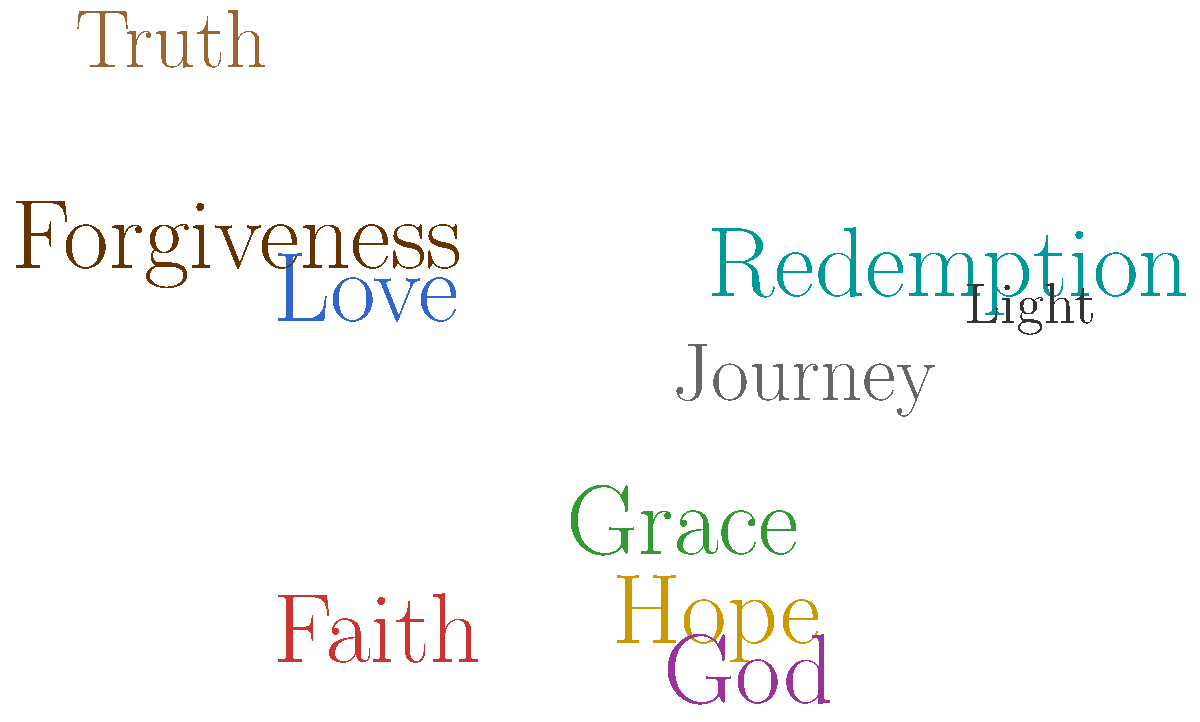Based on the word cloud representing Shawn McDonald's lyrical themes, which concept appears to be the most prominent and central to his music? To answer this question, we need to analyze the word cloud and consider the following steps:

1. Examine the size of the words: In a word cloud, the size of each word typically represents its frequency or importance in the subject matter.

2. Look for the largest word: In this word cloud, the word "God" appears to be the largest, indicating it's the most prominent theme.

3. Consider the color and positioning: While color and positioning can sometimes provide additional context, in this case, the size is the most crucial factor.

4. Reflect on Shawn McDonald's music: As a die-hard fan, you'd recognize that "God" being the central theme aligns with McDonald's Christian music background and his focus on faith-based lyrics.

5. Examine other prominent words: Words like "Love," "Faith," and "Grace" are also relatively large, supporting the overall spiritual and religious theme of McDonald's music.

6. Connect to McDonald's authenticity: The prominence of "God" in his lyrics reflects the honesty and authenticity in his music, which is something you, as a fan who appreciates these qualities, would recognize.

Therefore, based on the word cloud and our understanding of Shawn McDonald's music, the most prominent and central concept in his lyrical themes is "God."
Answer: God 